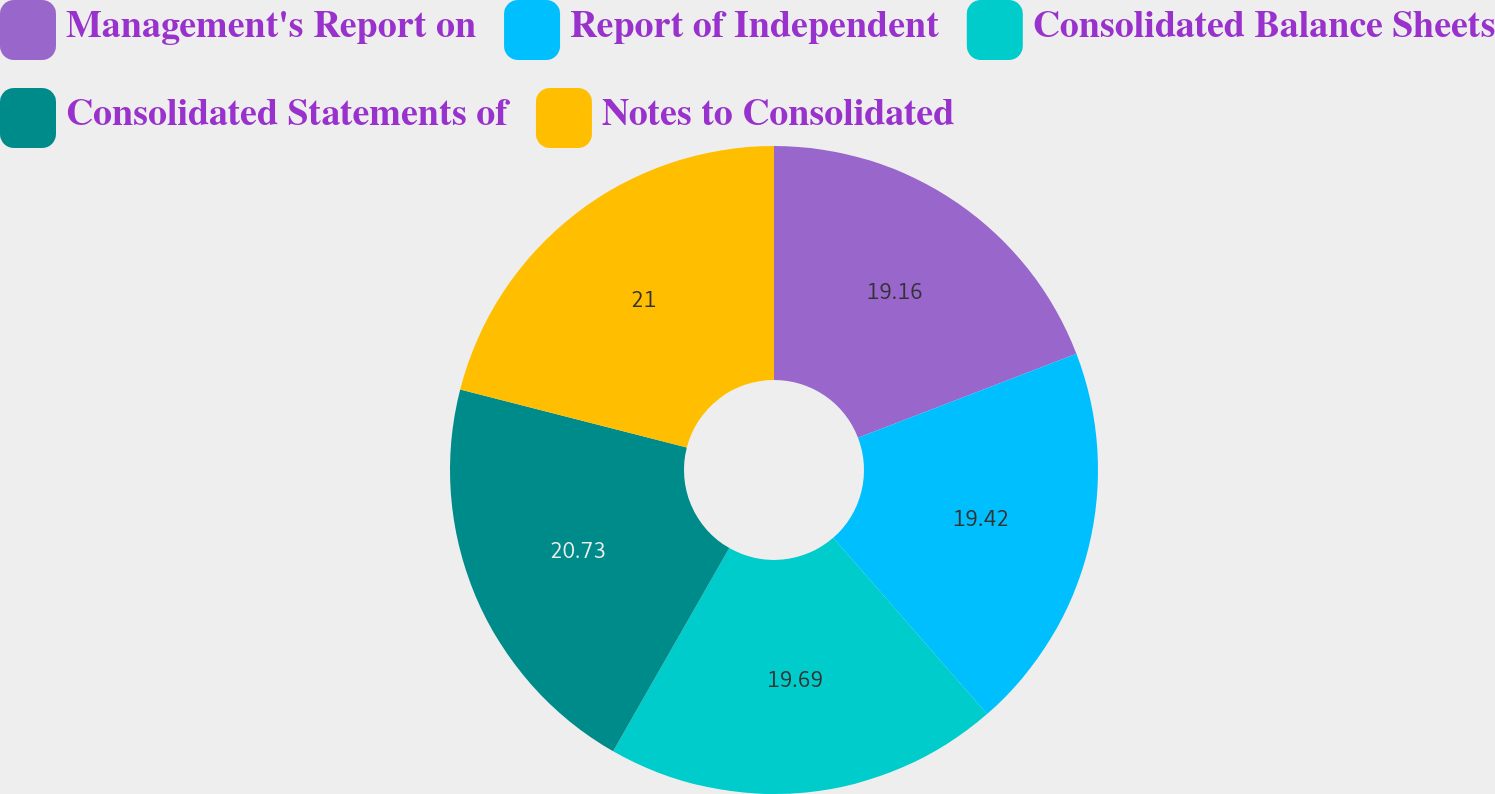<chart> <loc_0><loc_0><loc_500><loc_500><pie_chart><fcel>Management's Report on<fcel>Report of Independent<fcel>Consolidated Balance Sheets<fcel>Consolidated Statements of<fcel>Notes to Consolidated<nl><fcel>19.16%<fcel>19.42%<fcel>19.69%<fcel>20.73%<fcel>21.0%<nl></chart> 